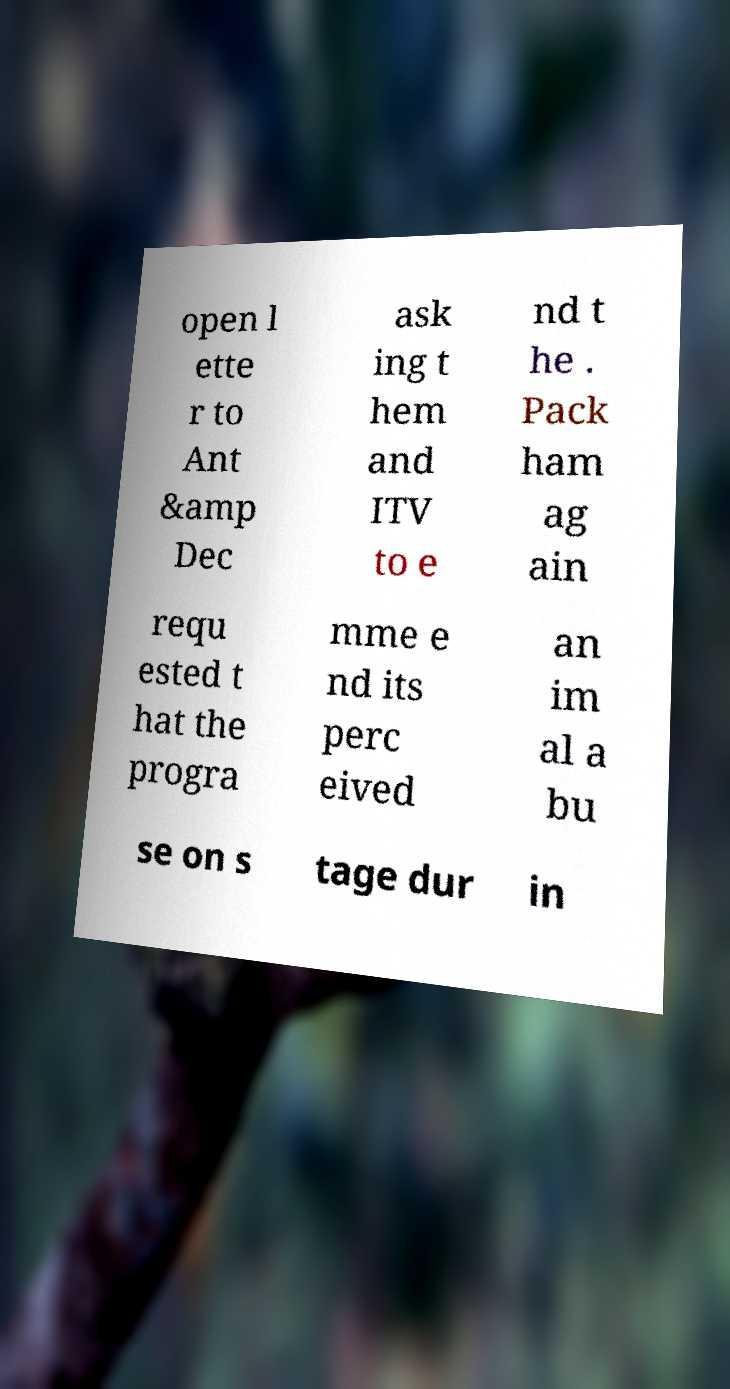What messages or text are displayed in this image? I need them in a readable, typed format. open l ette r to Ant &amp Dec ask ing t hem and ITV to e nd t he . Pack ham ag ain requ ested t hat the progra mme e nd its perc eived an im al a bu se on s tage dur in 